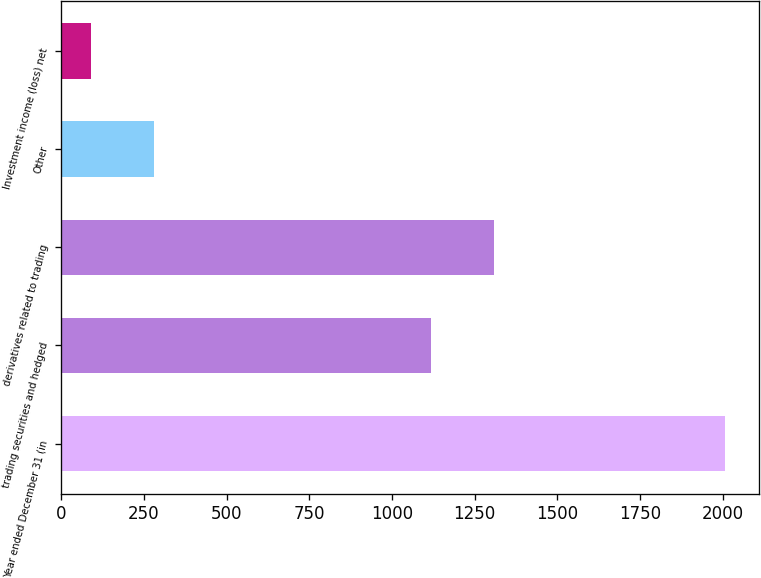Convert chart to OTSL. <chart><loc_0><loc_0><loc_500><loc_500><bar_chart><fcel>Year ended December 31 (in<fcel>trading securities and hedged<fcel>derivatives related to trading<fcel>Other<fcel>Investment income (loss) net<nl><fcel>2008<fcel>1117<fcel>1308.9<fcel>280.9<fcel>89<nl></chart> 